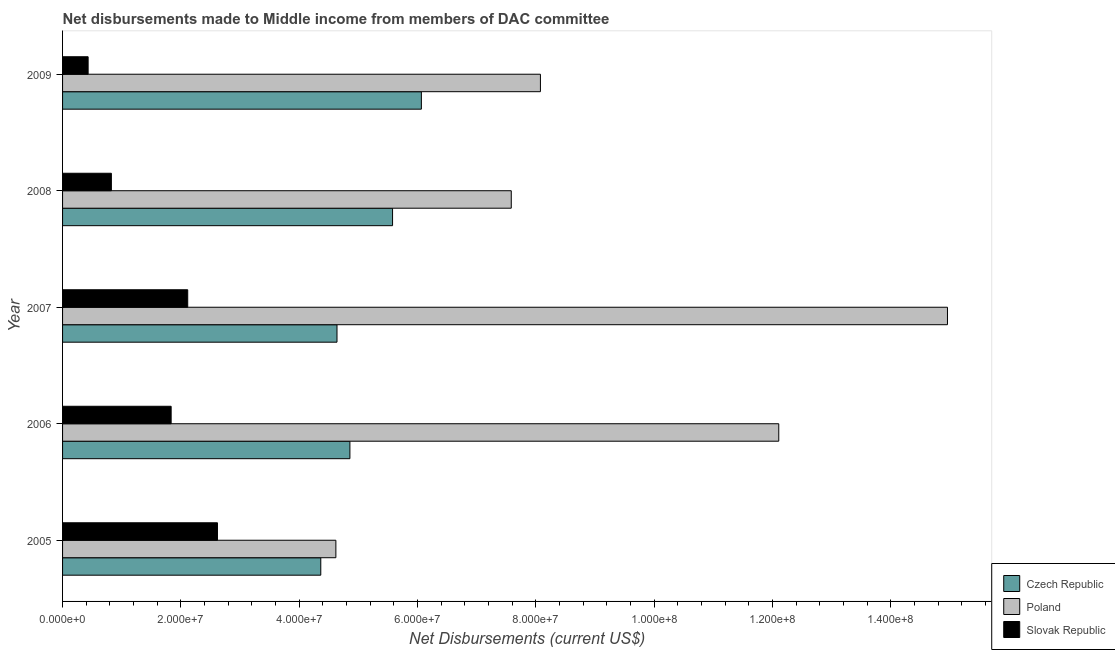How many different coloured bars are there?
Offer a very short reply. 3. How many groups of bars are there?
Offer a very short reply. 5. How many bars are there on the 2nd tick from the top?
Make the answer very short. 3. How many bars are there on the 5th tick from the bottom?
Your response must be concise. 3. In how many cases, is the number of bars for a given year not equal to the number of legend labels?
Give a very brief answer. 0. What is the net disbursements made by poland in 2008?
Give a very brief answer. 7.58e+07. Across all years, what is the maximum net disbursements made by poland?
Provide a short and direct response. 1.50e+08. Across all years, what is the minimum net disbursements made by slovak republic?
Make the answer very short. 4.32e+06. What is the total net disbursements made by czech republic in the graph?
Give a very brief answer. 2.55e+08. What is the difference between the net disbursements made by slovak republic in 2005 and that in 2009?
Make the answer very short. 2.19e+07. What is the difference between the net disbursements made by czech republic in 2007 and the net disbursements made by slovak republic in 2009?
Provide a succinct answer. 4.21e+07. What is the average net disbursements made by poland per year?
Keep it short and to the point. 9.47e+07. In the year 2005, what is the difference between the net disbursements made by slovak republic and net disbursements made by poland?
Your response must be concise. -2.00e+07. What is the ratio of the net disbursements made by poland in 2005 to that in 2006?
Your answer should be compact. 0.38. Is the net disbursements made by czech republic in 2007 less than that in 2008?
Make the answer very short. Yes. What is the difference between the highest and the second highest net disbursements made by czech republic?
Give a very brief answer. 4.87e+06. What is the difference between the highest and the lowest net disbursements made by poland?
Offer a terse response. 1.03e+08. Is the sum of the net disbursements made by slovak republic in 2006 and 2008 greater than the maximum net disbursements made by czech republic across all years?
Your answer should be compact. No. What does the 1st bar from the top in 2005 represents?
Provide a succinct answer. Slovak Republic. What does the 3rd bar from the bottom in 2006 represents?
Your answer should be very brief. Slovak Republic. Are all the bars in the graph horizontal?
Ensure brevity in your answer.  Yes. What is the difference between two consecutive major ticks on the X-axis?
Provide a short and direct response. 2.00e+07. Are the values on the major ticks of X-axis written in scientific E-notation?
Your answer should be compact. Yes. Does the graph contain any zero values?
Make the answer very short. No. Does the graph contain grids?
Your answer should be compact. No. How many legend labels are there?
Your response must be concise. 3. How are the legend labels stacked?
Provide a short and direct response. Vertical. What is the title of the graph?
Ensure brevity in your answer.  Net disbursements made to Middle income from members of DAC committee. Does "Poland" appear as one of the legend labels in the graph?
Your response must be concise. Yes. What is the label or title of the X-axis?
Your answer should be very brief. Net Disbursements (current US$). What is the Net Disbursements (current US$) in Czech Republic in 2005?
Your answer should be very brief. 4.36e+07. What is the Net Disbursements (current US$) of Poland in 2005?
Your answer should be very brief. 4.62e+07. What is the Net Disbursements (current US$) in Slovak Republic in 2005?
Your response must be concise. 2.62e+07. What is the Net Disbursements (current US$) in Czech Republic in 2006?
Make the answer very short. 4.86e+07. What is the Net Disbursements (current US$) in Poland in 2006?
Offer a very short reply. 1.21e+08. What is the Net Disbursements (current US$) in Slovak Republic in 2006?
Your response must be concise. 1.84e+07. What is the Net Disbursements (current US$) in Czech Republic in 2007?
Provide a short and direct response. 4.64e+07. What is the Net Disbursements (current US$) of Poland in 2007?
Ensure brevity in your answer.  1.50e+08. What is the Net Disbursements (current US$) of Slovak Republic in 2007?
Offer a very short reply. 2.12e+07. What is the Net Disbursements (current US$) in Czech Republic in 2008?
Your answer should be very brief. 5.58e+07. What is the Net Disbursements (current US$) in Poland in 2008?
Keep it short and to the point. 7.58e+07. What is the Net Disbursements (current US$) of Slovak Republic in 2008?
Give a very brief answer. 8.25e+06. What is the Net Disbursements (current US$) in Czech Republic in 2009?
Make the answer very short. 6.06e+07. What is the Net Disbursements (current US$) in Poland in 2009?
Give a very brief answer. 8.08e+07. What is the Net Disbursements (current US$) in Slovak Republic in 2009?
Provide a succinct answer. 4.32e+06. Across all years, what is the maximum Net Disbursements (current US$) of Czech Republic?
Offer a very short reply. 6.06e+07. Across all years, what is the maximum Net Disbursements (current US$) of Poland?
Your answer should be compact. 1.50e+08. Across all years, what is the maximum Net Disbursements (current US$) in Slovak Republic?
Ensure brevity in your answer.  2.62e+07. Across all years, what is the minimum Net Disbursements (current US$) in Czech Republic?
Give a very brief answer. 4.36e+07. Across all years, what is the minimum Net Disbursements (current US$) of Poland?
Keep it short and to the point. 4.62e+07. Across all years, what is the minimum Net Disbursements (current US$) of Slovak Republic?
Offer a very short reply. 4.32e+06. What is the total Net Disbursements (current US$) in Czech Republic in the graph?
Make the answer very short. 2.55e+08. What is the total Net Disbursements (current US$) of Poland in the graph?
Make the answer very short. 4.73e+08. What is the total Net Disbursements (current US$) in Slovak Republic in the graph?
Your answer should be very brief. 7.82e+07. What is the difference between the Net Disbursements (current US$) in Czech Republic in 2005 and that in 2006?
Provide a succinct answer. -4.92e+06. What is the difference between the Net Disbursements (current US$) in Poland in 2005 and that in 2006?
Give a very brief answer. -7.48e+07. What is the difference between the Net Disbursements (current US$) in Slovak Republic in 2005 and that in 2006?
Offer a very short reply. 7.83e+06. What is the difference between the Net Disbursements (current US$) in Czech Republic in 2005 and that in 2007?
Your answer should be compact. -2.74e+06. What is the difference between the Net Disbursements (current US$) of Poland in 2005 and that in 2007?
Provide a succinct answer. -1.03e+08. What is the difference between the Net Disbursements (current US$) of Slovak Republic in 2005 and that in 2007?
Provide a short and direct response. 5.03e+06. What is the difference between the Net Disbursements (current US$) of Czech Republic in 2005 and that in 2008?
Your answer should be compact. -1.21e+07. What is the difference between the Net Disbursements (current US$) in Poland in 2005 and that in 2008?
Your answer should be very brief. -2.96e+07. What is the difference between the Net Disbursements (current US$) of Slovak Republic in 2005 and that in 2008?
Provide a succinct answer. 1.79e+07. What is the difference between the Net Disbursements (current US$) of Czech Republic in 2005 and that in 2009?
Provide a succinct answer. -1.70e+07. What is the difference between the Net Disbursements (current US$) in Poland in 2005 and that in 2009?
Provide a succinct answer. -3.46e+07. What is the difference between the Net Disbursements (current US$) of Slovak Republic in 2005 and that in 2009?
Your answer should be very brief. 2.19e+07. What is the difference between the Net Disbursements (current US$) of Czech Republic in 2006 and that in 2007?
Provide a short and direct response. 2.18e+06. What is the difference between the Net Disbursements (current US$) of Poland in 2006 and that in 2007?
Your answer should be compact. -2.85e+07. What is the difference between the Net Disbursements (current US$) of Slovak Republic in 2006 and that in 2007?
Your answer should be compact. -2.80e+06. What is the difference between the Net Disbursements (current US$) in Czech Republic in 2006 and that in 2008?
Your response must be concise. -7.21e+06. What is the difference between the Net Disbursements (current US$) in Poland in 2006 and that in 2008?
Offer a terse response. 4.52e+07. What is the difference between the Net Disbursements (current US$) of Slovak Republic in 2006 and that in 2008?
Your answer should be compact. 1.01e+07. What is the difference between the Net Disbursements (current US$) in Czech Republic in 2006 and that in 2009?
Make the answer very short. -1.21e+07. What is the difference between the Net Disbursements (current US$) in Poland in 2006 and that in 2009?
Make the answer very short. 4.03e+07. What is the difference between the Net Disbursements (current US$) in Slovak Republic in 2006 and that in 2009?
Give a very brief answer. 1.40e+07. What is the difference between the Net Disbursements (current US$) of Czech Republic in 2007 and that in 2008?
Your response must be concise. -9.39e+06. What is the difference between the Net Disbursements (current US$) in Poland in 2007 and that in 2008?
Your answer should be compact. 7.37e+07. What is the difference between the Net Disbursements (current US$) in Slovak Republic in 2007 and that in 2008?
Your answer should be very brief. 1.29e+07. What is the difference between the Net Disbursements (current US$) of Czech Republic in 2007 and that in 2009?
Make the answer very short. -1.43e+07. What is the difference between the Net Disbursements (current US$) in Poland in 2007 and that in 2009?
Provide a succinct answer. 6.88e+07. What is the difference between the Net Disbursements (current US$) in Slovak Republic in 2007 and that in 2009?
Make the answer very short. 1.68e+07. What is the difference between the Net Disbursements (current US$) in Czech Republic in 2008 and that in 2009?
Your answer should be very brief. -4.87e+06. What is the difference between the Net Disbursements (current US$) in Poland in 2008 and that in 2009?
Offer a terse response. -4.93e+06. What is the difference between the Net Disbursements (current US$) of Slovak Republic in 2008 and that in 2009?
Offer a very short reply. 3.93e+06. What is the difference between the Net Disbursements (current US$) in Czech Republic in 2005 and the Net Disbursements (current US$) in Poland in 2006?
Make the answer very short. -7.74e+07. What is the difference between the Net Disbursements (current US$) of Czech Republic in 2005 and the Net Disbursements (current US$) of Slovak Republic in 2006?
Your answer should be very brief. 2.53e+07. What is the difference between the Net Disbursements (current US$) of Poland in 2005 and the Net Disbursements (current US$) of Slovak Republic in 2006?
Provide a succinct answer. 2.78e+07. What is the difference between the Net Disbursements (current US$) in Czech Republic in 2005 and the Net Disbursements (current US$) in Poland in 2007?
Keep it short and to the point. -1.06e+08. What is the difference between the Net Disbursements (current US$) in Czech Republic in 2005 and the Net Disbursements (current US$) in Slovak Republic in 2007?
Offer a very short reply. 2.25e+07. What is the difference between the Net Disbursements (current US$) of Poland in 2005 and the Net Disbursements (current US$) of Slovak Republic in 2007?
Make the answer very short. 2.50e+07. What is the difference between the Net Disbursements (current US$) of Czech Republic in 2005 and the Net Disbursements (current US$) of Poland in 2008?
Ensure brevity in your answer.  -3.22e+07. What is the difference between the Net Disbursements (current US$) in Czech Republic in 2005 and the Net Disbursements (current US$) in Slovak Republic in 2008?
Your answer should be compact. 3.54e+07. What is the difference between the Net Disbursements (current US$) in Poland in 2005 and the Net Disbursements (current US$) in Slovak Republic in 2008?
Keep it short and to the point. 3.79e+07. What is the difference between the Net Disbursements (current US$) in Czech Republic in 2005 and the Net Disbursements (current US$) in Poland in 2009?
Offer a terse response. -3.71e+07. What is the difference between the Net Disbursements (current US$) in Czech Republic in 2005 and the Net Disbursements (current US$) in Slovak Republic in 2009?
Offer a very short reply. 3.93e+07. What is the difference between the Net Disbursements (current US$) of Poland in 2005 and the Net Disbursements (current US$) of Slovak Republic in 2009?
Provide a succinct answer. 4.19e+07. What is the difference between the Net Disbursements (current US$) of Czech Republic in 2006 and the Net Disbursements (current US$) of Poland in 2007?
Make the answer very short. -1.01e+08. What is the difference between the Net Disbursements (current US$) in Czech Republic in 2006 and the Net Disbursements (current US$) in Slovak Republic in 2007?
Offer a terse response. 2.74e+07. What is the difference between the Net Disbursements (current US$) in Poland in 2006 and the Net Disbursements (current US$) in Slovak Republic in 2007?
Your answer should be compact. 9.99e+07. What is the difference between the Net Disbursements (current US$) of Czech Republic in 2006 and the Net Disbursements (current US$) of Poland in 2008?
Your answer should be compact. -2.73e+07. What is the difference between the Net Disbursements (current US$) of Czech Republic in 2006 and the Net Disbursements (current US$) of Slovak Republic in 2008?
Your response must be concise. 4.03e+07. What is the difference between the Net Disbursements (current US$) in Poland in 2006 and the Net Disbursements (current US$) in Slovak Republic in 2008?
Provide a short and direct response. 1.13e+08. What is the difference between the Net Disbursements (current US$) in Czech Republic in 2006 and the Net Disbursements (current US$) in Poland in 2009?
Your answer should be compact. -3.22e+07. What is the difference between the Net Disbursements (current US$) of Czech Republic in 2006 and the Net Disbursements (current US$) of Slovak Republic in 2009?
Keep it short and to the point. 4.42e+07. What is the difference between the Net Disbursements (current US$) in Poland in 2006 and the Net Disbursements (current US$) in Slovak Republic in 2009?
Ensure brevity in your answer.  1.17e+08. What is the difference between the Net Disbursements (current US$) in Czech Republic in 2007 and the Net Disbursements (current US$) in Poland in 2008?
Provide a short and direct response. -2.94e+07. What is the difference between the Net Disbursements (current US$) in Czech Republic in 2007 and the Net Disbursements (current US$) in Slovak Republic in 2008?
Your answer should be very brief. 3.81e+07. What is the difference between the Net Disbursements (current US$) of Poland in 2007 and the Net Disbursements (current US$) of Slovak Republic in 2008?
Make the answer very short. 1.41e+08. What is the difference between the Net Disbursements (current US$) of Czech Republic in 2007 and the Net Disbursements (current US$) of Poland in 2009?
Ensure brevity in your answer.  -3.44e+07. What is the difference between the Net Disbursements (current US$) of Czech Republic in 2007 and the Net Disbursements (current US$) of Slovak Republic in 2009?
Offer a very short reply. 4.21e+07. What is the difference between the Net Disbursements (current US$) in Poland in 2007 and the Net Disbursements (current US$) in Slovak Republic in 2009?
Provide a short and direct response. 1.45e+08. What is the difference between the Net Disbursements (current US$) of Czech Republic in 2008 and the Net Disbursements (current US$) of Poland in 2009?
Your response must be concise. -2.50e+07. What is the difference between the Net Disbursements (current US$) in Czech Republic in 2008 and the Net Disbursements (current US$) in Slovak Republic in 2009?
Your answer should be compact. 5.14e+07. What is the difference between the Net Disbursements (current US$) of Poland in 2008 and the Net Disbursements (current US$) of Slovak Republic in 2009?
Your answer should be very brief. 7.15e+07. What is the average Net Disbursements (current US$) of Czech Republic per year?
Provide a succinct answer. 5.10e+07. What is the average Net Disbursements (current US$) of Poland per year?
Provide a short and direct response. 9.47e+07. What is the average Net Disbursements (current US$) of Slovak Republic per year?
Your answer should be very brief. 1.56e+07. In the year 2005, what is the difference between the Net Disbursements (current US$) in Czech Republic and Net Disbursements (current US$) in Poland?
Ensure brevity in your answer.  -2.55e+06. In the year 2005, what is the difference between the Net Disbursements (current US$) of Czech Republic and Net Disbursements (current US$) of Slovak Republic?
Offer a terse response. 1.75e+07. In the year 2005, what is the difference between the Net Disbursements (current US$) of Poland and Net Disbursements (current US$) of Slovak Republic?
Ensure brevity in your answer.  2.00e+07. In the year 2006, what is the difference between the Net Disbursements (current US$) of Czech Republic and Net Disbursements (current US$) of Poland?
Provide a succinct answer. -7.25e+07. In the year 2006, what is the difference between the Net Disbursements (current US$) of Czech Republic and Net Disbursements (current US$) of Slovak Republic?
Provide a succinct answer. 3.02e+07. In the year 2006, what is the difference between the Net Disbursements (current US$) of Poland and Net Disbursements (current US$) of Slovak Republic?
Make the answer very short. 1.03e+08. In the year 2007, what is the difference between the Net Disbursements (current US$) of Czech Republic and Net Disbursements (current US$) of Poland?
Keep it short and to the point. -1.03e+08. In the year 2007, what is the difference between the Net Disbursements (current US$) in Czech Republic and Net Disbursements (current US$) in Slovak Republic?
Offer a terse response. 2.52e+07. In the year 2007, what is the difference between the Net Disbursements (current US$) in Poland and Net Disbursements (current US$) in Slovak Republic?
Your answer should be compact. 1.28e+08. In the year 2008, what is the difference between the Net Disbursements (current US$) of Czech Republic and Net Disbursements (current US$) of Poland?
Provide a succinct answer. -2.01e+07. In the year 2008, what is the difference between the Net Disbursements (current US$) in Czech Republic and Net Disbursements (current US$) in Slovak Republic?
Give a very brief answer. 4.75e+07. In the year 2008, what is the difference between the Net Disbursements (current US$) in Poland and Net Disbursements (current US$) in Slovak Republic?
Provide a short and direct response. 6.76e+07. In the year 2009, what is the difference between the Net Disbursements (current US$) in Czech Republic and Net Disbursements (current US$) in Poland?
Provide a short and direct response. -2.01e+07. In the year 2009, what is the difference between the Net Disbursements (current US$) of Czech Republic and Net Disbursements (current US$) of Slovak Republic?
Provide a succinct answer. 5.63e+07. In the year 2009, what is the difference between the Net Disbursements (current US$) of Poland and Net Disbursements (current US$) of Slovak Republic?
Your answer should be compact. 7.64e+07. What is the ratio of the Net Disbursements (current US$) of Czech Republic in 2005 to that in 2006?
Provide a short and direct response. 0.9. What is the ratio of the Net Disbursements (current US$) in Poland in 2005 to that in 2006?
Your response must be concise. 0.38. What is the ratio of the Net Disbursements (current US$) of Slovak Republic in 2005 to that in 2006?
Your response must be concise. 1.43. What is the ratio of the Net Disbursements (current US$) of Czech Republic in 2005 to that in 2007?
Provide a short and direct response. 0.94. What is the ratio of the Net Disbursements (current US$) in Poland in 2005 to that in 2007?
Make the answer very short. 0.31. What is the ratio of the Net Disbursements (current US$) of Slovak Republic in 2005 to that in 2007?
Provide a succinct answer. 1.24. What is the ratio of the Net Disbursements (current US$) in Czech Republic in 2005 to that in 2008?
Offer a terse response. 0.78. What is the ratio of the Net Disbursements (current US$) of Poland in 2005 to that in 2008?
Your response must be concise. 0.61. What is the ratio of the Net Disbursements (current US$) in Slovak Republic in 2005 to that in 2008?
Provide a short and direct response. 3.17. What is the ratio of the Net Disbursements (current US$) of Czech Republic in 2005 to that in 2009?
Your response must be concise. 0.72. What is the ratio of the Net Disbursements (current US$) of Poland in 2005 to that in 2009?
Provide a short and direct response. 0.57. What is the ratio of the Net Disbursements (current US$) in Slovak Republic in 2005 to that in 2009?
Offer a very short reply. 6.06. What is the ratio of the Net Disbursements (current US$) in Czech Republic in 2006 to that in 2007?
Keep it short and to the point. 1.05. What is the ratio of the Net Disbursements (current US$) in Poland in 2006 to that in 2007?
Give a very brief answer. 0.81. What is the ratio of the Net Disbursements (current US$) in Slovak Republic in 2006 to that in 2007?
Ensure brevity in your answer.  0.87. What is the ratio of the Net Disbursements (current US$) of Czech Republic in 2006 to that in 2008?
Offer a very short reply. 0.87. What is the ratio of the Net Disbursements (current US$) of Poland in 2006 to that in 2008?
Your answer should be compact. 1.6. What is the ratio of the Net Disbursements (current US$) of Slovak Republic in 2006 to that in 2008?
Make the answer very short. 2.22. What is the ratio of the Net Disbursements (current US$) in Czech Republic in 2006 to that in 2009?
Your answer should be very brief. 0.8. What is the ratio of the Net Disbursements (current US$) of Poland in 2006 to that in 2009?
Offer a very short reply. 1.5. What is the ratio of the Net Disbursements (current US$) in Slovak Republic in 2006 to that in 2009?
Offer a terse response. 4.25. What is the ratio of the Net Disbursements (current US$) of Czech Republic in 2007 to that in 2008?
Keep it short and to the point. 0.83. What is the ratio of the Net Disbursements (current US$) in Poland in 2007 to that in 2008?
Your answer should be very brief. 1.97. What is the ratio of the Net Disbursements (current US$) in Slovak Republic in 2007 to that in 2008?
Keep it short and to the point. 2.56. What is the ratio of the Net Disbursements (current US$) in Czech Republic in 2007 to that in 2009?
Make the answer very short. 0.76. What is the ratio of the Net Disbursements (current US$) in Poland in 2007 to that in 2009?
Give a very brief answer. 1.85. What is the ratio of the Net Disbursements (current US$) in Slovak Republic in 2007 to that in 2009?
Your response must be concise. 4.9. What is the ratio of the Net Disbursements (current US$) in Czech Republic in 2008 to that in 2009?
Keep it short and to the point. 0.92. What is the ratio of the Net Disbursements (current US$) of Poland in 2008 to that in 2009?
Provide a succinct answer. 0.94. What is the ratio of the Net Disbursements (current US$) in Slovak Republic in 2008 to that in 2009?
Offer a very short reply. 1.91. What is the difference between the highest and the second highest Net Disbursements (current US$) in Czech Republic?
Make the answer very short. 4.87e+06. What is the difference between the highest and the second highest Net Disbursements (current US$) in Poland?
Offer a very short reply. 2.85e+07. What is the difference between the highest and the second highest Net Disbursements (current US$) in Slovak Republic?
Your answer should be very brief. 5.03e+06. What is the difference between the highest and the lowest Net Disbursements (current US$) of Czech Republic?
Your response must be concise. 1.70e+07. What is the difference between the highest and the lowest Net Disbursements (current US$) in Poland?
Make the answer very short. 1.03e+08. What is the difference between the highest and the lowest Net Disbursements (current US$) in Slovak Republic?
Give a very brief answer. 2.19e+07. 